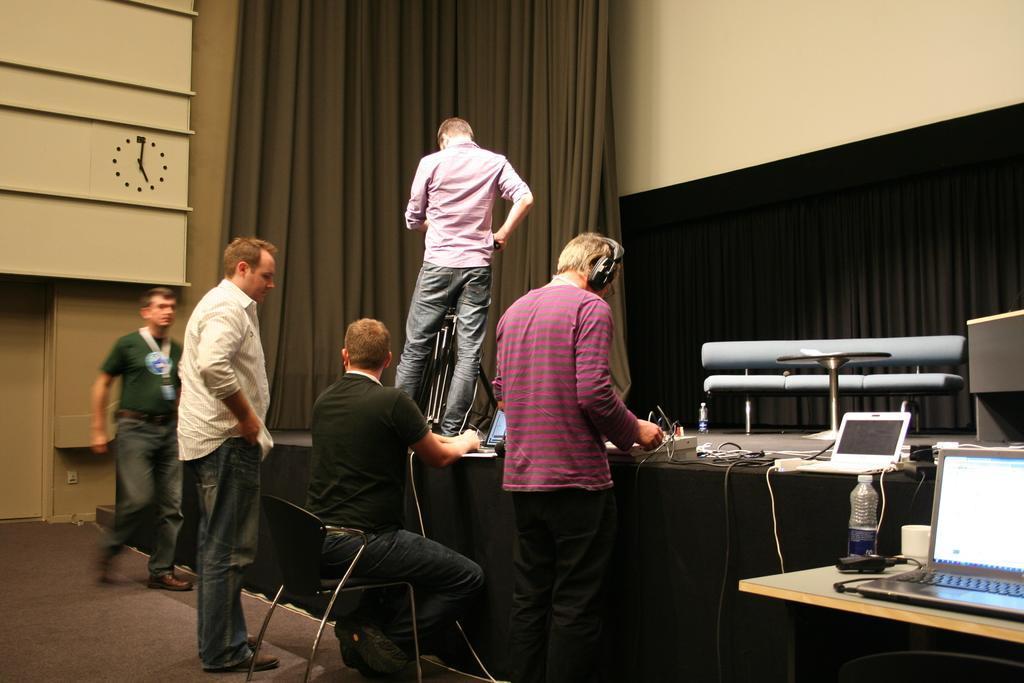Describe this image in one or two sentences. This person is standing on stage. On stage there is a couch, table, laptop and cables. This person is sitting on a chair. This 3 persons are standing on floor. This person wore headset. On this table there is a laptop and bottle. This is a curtain. A clock on wall. 